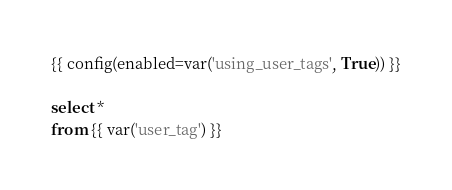Convert code to text. <code><loc_0><loc_0><loc_500><loc_500><_SQL_>{{ config(enabled=var('using_user_tags', True)) }}

select * 
from {{ var('user_tag') }}
</code> 